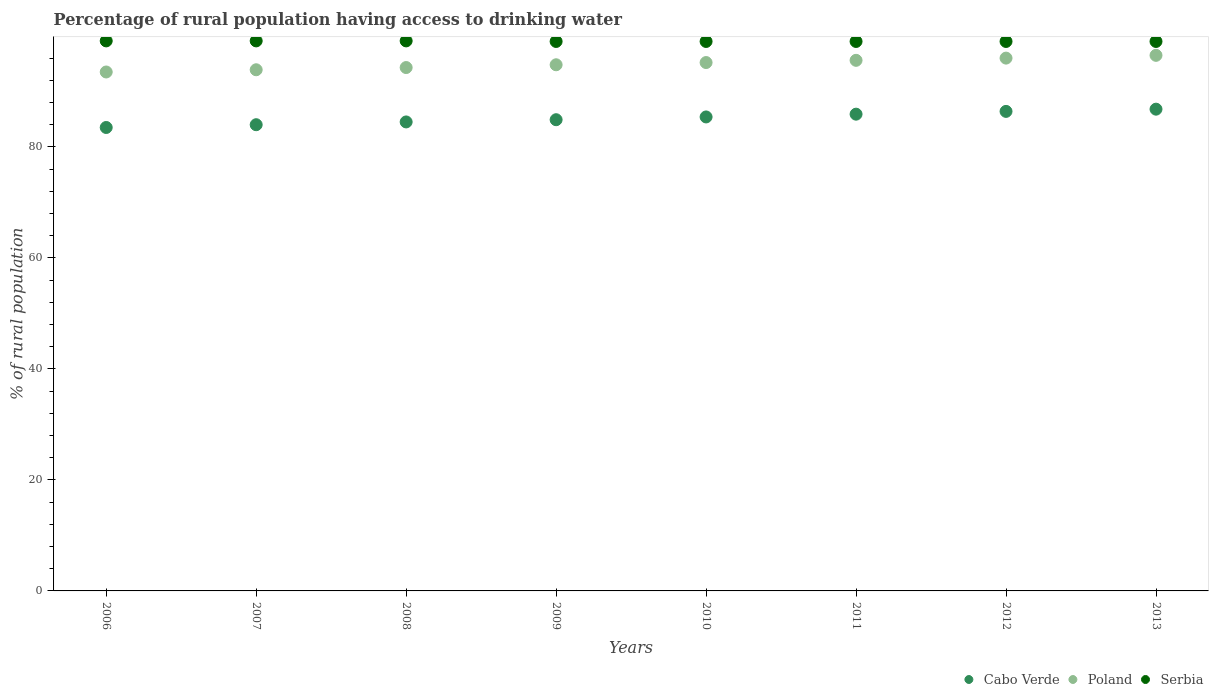Is the number of dotlines equal to the number of legend labels?
Your answer should be very brief. Yes. What is the percentage of rural population having access to drinking water in Poland in 2011?
Ensure brevity in your answer.  95.6. Across all years, what is the maximum percentage of rural population having access to drinking water in Serbia?
Your answer should be very brief. 99.1. Across all years, what is the minimum percentage of rural population having access to drinking water in Serbia?
Your answer should be very brief. 99. In which year was the percentage of rural population having access to drinking water in Cabo Verde maximum?
Your answer should be compact. 2013. In which year was the percentage of rural population having access to drinking water in Serbia minimum?
Ensure brevity in your answer.  2009. What is the total percentage of rural population having access to drinking water in Poland in the graph?
Provide a short and direct response. 759.8. What is the average percentage of rural population having access to drinking water in Serbia per year?
Provide a short and direct response. 99.04. In the year 2012, what is the difference between the percentage of rural population having access to drinking water in Poland and percentage of rural population having access to drinking water in Cabo Verde?
Keep it short and to the point. 9.6. In how many years, is the percentage of rural population having access to drinking water in Poland greater than 92 %?
Your response must be concise. 8. Is the percentage of rural population having access to drinking water in Poland in 2008 less than that in 2013?
Your response must be concise. Yes. Is the difference between the percentage of rural population having access to drinking water in Poland in 2009 and 2013 greater than the difference between the percentage of rural population having access to drinking water in Cabo Verde in 2009 and 2013?
Offer a terse response. Yes. What is the difference between the highest and the lowest percentage of rural population having access to drinking water in Cabo Verde?
Offer a terse response. 3.3. Is it the case that in every year, the sum of the percentage of rural population having access to drinking water in Poland and percentage of rural population having access to drinking water in Serbia  is greater than the percentage of rural population having access to drinking water in Cabo Verde?
Provide a short and direct response. Yes. Does the percentage of rural population having access to drinking water in Serbia monotonically increase over the years?
Make the answer very short. No. Is the percentage of rural population having access to drinking water in Poland strictly less than the percentage of rural population having access to drinking water in Serbia over the years?
Offer a terse response. Yes. How many years are there in the graph?
Keep it short and to the point. 8. Are the values on the major ticks of Y-axis written in scientific E-notation?
Provide a short and direct response. No. How many legend labels are there?
Ensure brevity in your answer.  3. How are the legend labels stacked?
Offer a very short reply. Horizontal. What is the title of the graph?
Your answer should be very brief. Percentage of rural population having access to drinking water. Does "Kosovo" appear as one of the legend labels in the graph?
Your answer should be very brief. No. What is the label or title of the X-axis?
Offer a very short reply. Years. What is the label or title of the Y-axis?
Offer a very short reply. % of rural population. What is the % of rural population in Cabo Verde in 2006?
Provide a succinct answer. 83.5. What is the % of rural population in Poland in 2006?
Your response must be concise. 93.5. What is the % of rural population in Serbia in 2006?
Provide a succinct answer. 99.1. What is the % of rural population of Poland in 2007?
Offer a very short reply. 93.9. What is the % of rural population of Serbia in 2007?
Your answer should be compact. 99.1. What is the % of rural population of Cabo Verde in 2008?
Provide a short and direct response. 84.5. What is the % of rural population in Poland in 2008?
Make the answer very short. 94.3. What is the % of rural population of Serbia in 2008?
Ensure brevity in your answer.  99.1. What is the % of rural population of Cabo Verde in 2009?
Offer a terse response. 84.9. What is the % of rural population of Poland in 2009?
Provide a succinct answer. 94.8. What is the % of rural population in Serbia in 2009?
Your answer should be compact. 99. What is the % of rural population in Cabo Verde in 2010?
Your answer should be compact. 85.4. What is the % of rural population in Poland in 2010?
Keep it short and to the point. 95.2. What is the % of rural population in Serbia in 2010?
Provide a short and direct response. 99. What is the % of rural population in Cabo Verde in 2011?
Provide a succinct answer. 85.9. What is the % of rural population in Poland in 2011?
Your response must be concise. 95.6. What is the % of rural population in Serbia in 2011?
Keep it short and to the point. 99. What is the % of rural population in Cabo Verde in 2012?
Provide a succinct answer. 86.4. What is the % of rural population of Poland in 2012?
Give a very brief answer. 96. What is the % of rural population in Cabo Verde in 2013?
Provide a short and direct response. 86.8. What is the % of rural population in Poland in 2013?
Your answer should be very brief. 96.5. Across all years, what is the maximum % of rural population of Cabo Verde?
Offer a terse response. 86.8. Across all years, what is the maximum % of rural population in Poland?
Provide a succinct answer. 96.5. Across all years, what is the maximum % of rural population in Serbia?
Offer a very short reply. 99.1. Across all years, what is the minimum % of rural population in Cabo Verde?
Provide a succinct answer. 83.5. Across all years, what is the minimum % of rural population of Poland?
Offer a very short reply. 93.5. What is the total % of rural population of Cabo Verde in the graph?
Give a very brief answer. 681.4. What is the total % of rural population of Poland in the graph?
Your answer should be compact. 759.8. What is the total % of rural population in Serbia in the graph?
Keep it short and to the point. 792.3. What is the difference between the % of rural population of Cabo Verde in 2006 and that in 2007?
Your response must be concise. -0.5. What is the difference between the % of rural population in Poland in 2006 and that in 2007?
Provide a succinct answer. -0.4. What is the difference between the % of rural population of Serbia in 2006 and that in 2007?
Provide a short and direct response. 0. What is the difference between the % of rural population of Cabo Verde in 2006 and that in 2008?
Make the answer very short. -1. What is the difference between the % of rural population in Poland in 2006 and that in 2008?
Your answer should be compact. -0.8. What is the difference between the % of rural population of Serbia in 2006 and that in 2008?
Your response must be concise. 0. What is the difference between the % of rural population of Cabo Verde in 2006 and that in 2010?
Your answer should be compact. -1.9. What is the difference between the % of rural population of Cabo Verde in 2006 and that in 2011?
Your answer should be compact. -2.4. What is the difference between the % of rural population in Serbia in 2006 and that in 2011?
Keep it short and to the point. 0.1. What is the difference between the % of rural population of Cabo Verde in 2006 and that in 2012?
Your answer should be compact. -2.9. What is the difference between the % of rural population of Serbia in 2006 and that in 2012?
Your answer should be very brief. 0.1. What is the difference between the % of rural population in Cabo Verde in 2006 and that in 2013?
Offer a very short reply. -3.3. What is the difference between the % of rural population of Serbia in 2006 and that in 2013?
Your answer should be compact. 0.1. What is the difference between the % of rural population of Cabo Verde in 2007 and that in 2009?
Offer a terse response. -0.9. What is the difference between the % of rural population in Cabo Verde in 2007 and that in 2010?
Offer a very short reply. -1.4. What is the difference between the % of rural population of Cabo Verde in 2007 and that in 2011?
Provide a short and direct response. -1.9. What is the difference between the % of rural population in Poland in 2007 and that in 2011?
Your answer should be very brief. -1.7. What is the difference between the % of rural population in Serbia in 2007 and that in 2011?
Your response must be concise. 0.1. What is the difference between the % of rural population in Cabo Verde in 2007 and that in 2012?
Your answer should be very brief. -2.4. What is the difference between the % of rural population of Serbia in 2007 and that in 2012?
Your answer should be compact. 0.1. What is the difference between the % of rural population in Poland in 2008 and that in 2009?
Provide a succinct answer. -0.5. What is the difference between the % of rural population of Cabo Verde in 2008 and that in 2010?
Keep it short and to the point. -0.9. What is the difference between the % of rural population in Serbia in 2008 and that in 2010?
Provide a succinct answer. 0.1. What is the difference between the % of rural population of Serbia in 2008 and that in 2011?
Make the answer very short. 0.1. What is the difference between the % of rural population in Poland in 2009 and that in 2010?
Your response must be concise. -0.4. What is the difference between the % of rural population of Serbia in 2009 and that in 2010?
Your response must be concise. 0. What is the difference between the % of rural population of Cabo Verde in 2009 and that in 2011?
Provide a succinct answer. -1. What is the difference between the % of rural population of Serbia in 2009 and that in 2011?
Your answer should be very brief. 0. What is the difference between the % of rural population of Cabo Verde in 2009 and that in 2012?
Your answer should be very brief. -1.5. What is the difference between the % of rural population of Cabo Verde in 2009 and that in 2013?
Offer a very short reply. -1.9. What is the difference between the % of rural population in Poland in 2009 and that in 2013?
Your response must be concise. -1.7. What is the difference between the % of rural population in Serbia in 2009 and that in 2013?
Your answer should be very brief. 0. What is the difference between the % of rural population of Cabo Verde in 2010 and that in 2012?
Ensure brevity in your answer.  -1. What is the difference between the % of rural population of Serbia in 2010 and that in 2013?
Provide a short and direct response. 0. What is the difference between the % of rural population in Cabo Verde in 2011 and that in 2012?
Make the answer very short. -0.5. What is the difference between the % of rural population of Serbia in 2011 and that in 2012?
Your answer should be compact. 0. What is the difference between the % of rural population of Poland in 2012 and that in 2013?
Provide a succinct answer. -0.5. What is the difference between the % of rural population in Serbia in 2012 and that in 2013?
Offer a very short reply. 0. What is the difference between the % of rural population in Cabo Verde in 2006 and the % of rural population in Serbia in 2007?
Ensure brevity in your answer.  -15.6. What is the difference between the % of rural population in Poland in 2006 and the % of rural population in Serbia in 2007?
Give a very brief answer. -5.6. What is the difference between the % of rural population of Cabo Verde in 2006 and the % of rural population of Serbia in 2008?
Offer a terse response. -15.6. What is the difference between the % of rural population of Poland in 2006 and the % of rural population of Serbia in 2008?
Give a very brief answer. -5.6. What is the difference between the % of rural population of Cabo Verde in 2006 and the % of rural population of Serbia in 2009?
Provide a succinct answer. -15.5. What is the difference between the % of rural population in Cabo Verde in 2006 and the % of rural population in Poland in 2010?
Your answer should be very brief. -11.7. What is the difference between the % of rural population in Cabo Verde in 2006 and the % of rural population in Serbia in 2010?
Your answer should be compact. -15.5. What is the difference between the % of rural population of Poland in 2006 and the % of rural population of Serbia in 2010?
Offer a terse response. -5.5. What is the difference between the % of rural population of Cabo Verde in 2006 and the % of rural population of Serbia in 2011?
Offer a very short reply. -15.5. What is the difference between the % of rural population of Cabo Verde in 2006 and the % of rural population of Poland in 2012?
Offer a terse response. -12.5. What is the difference between the % of rural population of Cabo Verde in 2006 and the % of rural population of Serbia in 2012?
Ensure brevity in your answer.  -15.5. What is the difference between the % of rural population in Poland in 2006 and the % of rural population in Serbia in 2012?
Offer a very short reply. -5.5. What is the difference between the % of rural population in Cabo Verde in 2006 and the % of rural population in Poland in 2013?
Keep it short and to the point. -13. What is the difference between the % of rural population of Cabo Verde in 2006 and the % of rural population of Serbia in 2013?
Give a very brief answer. -15.5. What is the difference between the % of rural population of Poland in 2006 and the % of rural population of Serbia in 2013?
Offer a very short reply. -5.5. What is the difference between the % of rural population of Cabo Verde in 2007 and the % of rural population of Serbia in 2008?
Your answer should be compact. -15.1. What is the difference between the % of rural population in Cabo Verde in 2007 and the % of rural population in Poland in 2009?
Keep it short and to the point. -10.8. What is the difference between the % of rural population in Poland in 2007 and the % of rural population in Serbia in 2009?
Ensure brevity in your answer.  -5.1. What is the difference between the % of rural population in Cabo Verde in 2007 and the % of rural population in Poland in 2010?
Keep it short and to the point. -11.2. What is the difference between the % of rural population of Cabo Verde in 2007 and the % of rural population of Serbia in 2010?
Your response must be concise. -15. What is the difference between the % of rural population of Cabo Verde in 2007 and the % of rural population of Serbia in 2011?
Ensure brevity in your answer.  -15. What is the difference between the % of rural population of Cabo Verde in 2007 and the % of rural population of Poland in 2012?
Give a very brief answer. -12. What is the difference between the % of rural population in Cabo Verde in 2007 and the % of rural population in Serbia in 2012?
Your response must be concise. -15. What is the difference between the % of rural population of Poland in 2007 and the % of rural population of Serbia in 2012?
Ensure brevity in your answer.  -5.1. What is the difference between the % of rural population in Cabo Verde in 2007 and the % of rural population in Poland in 2013?
Your response must be concise. -12.5. What is the difference between the % of rural population of Cabo Verde in 2008 and the % of rural population of Poland in 2009?
Make the answer very short. -10.3. What is the difference between the % of rural population in Cabo Verde in 2008 and the % of rural population in Serbia in 2009?
Provide a short and direct response. -14.5. What is the difference between the % of rural population in Cabo Verde in 2008 and the % of rural population in Poland in 2010?
Your response must be concise. -10.7. What is the difference between the % of rural population in Poland in 2008 and the % of rural population in Serbia in 2010?
Keep it short and to the point. -4.7. What is the difference between the % of rural population of Cabo Verde in 2008 and the % of rural population of Poland in 2011?
Your answer should be compact. -11.1. What is the difference between the % of rural population in Poland in 2008 and the % of rural population in Serbia in 2011?
Make the answer very short. -4.7. What is the difference between the % of rural population of Cabo Verde in 2008 and the % of rural population of Poland in 2012?
Your answer should be very brief. -11.5. What is the difference between the % of rural population in Cabo Verde in 2008 and the % of rural population in Serbia in 2012?
Your response must be concise. -14.5. What is the difference between the % of rural population of Poland in 2008 and the % of rural population of Serbia in 2012?
Your answer should be compact. -4.7. What is the difference between the % of rural population in Poland in 2008 and the % of rural population in Serbia in 2013?
Offer a terse response. -4.7. What is the difference between the % of rural population in Cabo Verde in 2009 and the % of rural population in Poland in 2010?
Ensure brevity in your answer.  -10.3. What is the difference between the % of rural population in Cabo Verde in 2009 and the % of rural population in Serbia in 2010?
Keep it short and to the point. -14.1. What is the difference between the % of rural population of Cabo Verde in 2009 and the % of rural population of Poland in 2011?
Make the answer very short. -10.7. What is the difference between the % of rural population in Cabo Verde in 2009 and the % of rural population in Serbia in 2011?
Your answer should be very brief. -14.1. What is the difference between the % of rural population of Poland in 2009 and the % of rural population of Serbia in 2011?
Ensure brevity in your answer.  -4.2. What is the difference between the % of rural population of Cabo Verde in 2009 and the % of rural population of Poland in 2012?
Offer a very short reply. -11.1. What is the difference between the % of rural population in Cabo Verde in 2009 and the % of rural population in Serbia in 2012?
Offer a very short reply. -14.1. What is the difference between the % of rural population of Poland in 2009 and the % of rural population of Serbia in 2012?
Give a very brief answer. -4.2. What is the difference between the % of rural population of Cabo Verde in 2009 and the % of rural population of Poland in 2013?
Provide a succinct answer. -11.6. What is the difference between the % of rural population of Cabo Verde in 2009 and the % of rural population of Serbia in 2013?
Your answer should be compact. -14.1. What is the difference between the % of rural population of Poland in 2009 and the % of rural population of Serbia in 2013?
Keep it short and to the point. -4.2. What is the difference between the % of rural population in Cabo Verde in 2010 and the % of rural population in Poland in 2012?
Ensure brevity in your answer.  -10.6. What is the difference between the % of rural population of Cabo Verde in 2011 and the % of rural population of Poland in 2012?
Give a very brief answer. -10.1. What is the difference between the % of rural population of Cabo Verde in 2011 and the % of rural population of Serbia in 2012?
Provide a short and direct response. -13.1. What is the difference between the % of rural population of Cabo Verde in 2011 and the % of rural population of Serbia in 2013?
Provide a short and direct response. -13.1. What is the difference between the % of rural population of Cabo Verde in 2012 and the % of rural population of Poland in 2013?
Offer a terse response. -10.1. What is the difference between the % of rural population in Poland in 2012 and the % of rural population in Serbia in 2013?
Your response must be concise. -3. What is the average % of rural population in Cabo Verde per year?
Offer a very short reply. 85.17. What is the average % of rural population of Poland per year?
Keep it short and to the point. 94.97. What is the average % of rural population in Serbia per year?
Keep it short and to the point. 99.04. In the year 2006, what is the difference between the % of rural population of Cabo Verde and % of rural population of Poland?
Keep it short and to the point. -10. In the year 2006, what is the difference between the % of rural population of Cabo Verde and % of rural population of Serbia?
Give a very brief answer. -15.6. In the year 2007, what is the difference between the % of rural population of Cabo Verde and % of rural population of Serbia?
Offer a terse response. -15.1. In the year 2008, what is the difference between the % of rural population in Cabo Verde and % of rural population in Serbia?
Offer a very short reply. -14.6. In the year 2009, what is the difference between the % of rural population in Cabo Verde and % of rural population in Serbia?
Provide a succinct answer. -14.1. In the year 2010, what is the difference between the % of rural population in Cabo Verde and % of rural population in Poland?
Keep it short and to the point. -9.8. In the year 2011, what is the difference between the % of rural population of Cabo Verde and % of rural population of Serbia?
Offer a terse response. -13.1. In the year 2011, what is the difference between the % of rural population of Poland and % of rural population of Serbia?
Provide a short and direct response. -3.4. In the year 2012, what is the difference between the % of rural population in Cabo Verde and % of rural population in Poland?
Keep it short and to the point. -9.6. In the year 2012, what is the difference between the % of rural population of Poland and % of rural population of Serbia?
Provide a short and direct response. -3. In the year 2013, what is the difference between the % of rural population in Cabo Verde and % of rural population in Poland?
Your answer should be compact. -9.7. In the year 2013, what is the difference between the % of rural population in Cabo Verde and % of rural population in Serbia?
Give a very brief answer. -12.2. In the year 2013, what is the difference between the % of rural population in Poland and % of rural population in Serbia?
Make the answer very short. -2.5. What is the ratio of the % of rural population of Cabo Verde in 2006 to that in 2007?
Offer a very short reply. 0.99. What is the ratio of the % of rural population in Poland in 2006 to that in 2007?
Ensure brevity in your answer.  1. What is the ratio of the % of rural population of Serbia in 2006 to that in 2007?
Your answer should be very brief. 1. What is the ratio of the % of rural population of Cabo Verde in 2006 to that in 2008?
Provide a short and direct response. 0.99. What is the ratio of the % of rural population of Cabo Verde in 2006 to that in 2009?
Provide a short and direct response. 0.98. What is the ratio of the % of rural population of Poland in 2006 to that in 2009?
Keep it short and to the point. 0.99. What is the ratio of the % of rural population in Cabo Verde in 2006 to that in 2010?
Ensure brevity in your answer.  0.98. What is the ratio of the % of rural population of Poland in 2006 to that in 2010?
Keep it short and to the point. 0.98. What is the ratio of the % of rural population in Serbia in 2006 to that in 2010?
Ensure brevity in your answer.  1. What is the ratio of the % of rural population of Cabo Verde in 2006 to that in 2011?
Provide a short and direct response. 0.97. What is the ratio of the % of rural population of Poland in 2006 to that in 2011?
Provide a succinct answer. 0.98. What is the ratio of the % of rural population in Serbia in 2006 to that in 2011?
Offer a very short reply. 1. What is the ratio of the % of rural population of Cabo Verde in 2006 to that in 2012?
Make the answer very short. 0.97. What is the ratio of the % of rural population in Cabo Verde in 2006 to that in 2013?
Provide a succinct answer. 0.96. What is the ratio of the % of rural population of Poland in 2006 to that in 2013?
Ensure brevity in your answer.  0.97. What is the ratio of the % of rural population of Serbia in 2006 to that in 2013?
Make the answer very short. 1. What is the ratio of the % of rural population of Cabo Verde in 2007 to that in 2008?
Offer a terse response. 0.99. What is the ratio of the % of rural population of Cabo Verde in 2007 to that in 2009?
Provide a short and direct response. 0.99. What is the ratio of the % of rural population in Serbia in 2007 to that in 2009?
Your answer should be compact. 1. What is the ratio of the % of rural population of Cabo Verde in 2007 to that in 2010?
Ensure brevity in your answer.  0.98. What is the ratio of the % of rural population of Poland in 2007 to that in 2010?
Your response must be concise. 0.99. What is the ratio of the % of rural population in Serbia in 2007 to that in 2010?
Offer a terse response. 1. What is the ratio of the % of rural population of Cabo Verde in 2007 to that in 2011?
Ensure brevity in your answer.  0.98. What is the ratio of the % of rural population of Poland in 2007 to that in 2011?
Keep it short and to the point. 0.98. What is the ratio of the % of rural population in Serbia in 2007 to that in 2011?
Offer a very short reply. 1. What is the ratio of the % of rural population of Cabo Verde in 2007 to that in 2012?
Make the answer very short. 0.97. What is the ratio of the % of rural population in Poland in 2007 to that in 2012?
Your answer should be very brief. 0.98. What is the ratio of the % of rural population of Cabo Verde in 2007 to that in 2013?
Keep it short and to the point. 0.97. What is the ratio of the % of rural population of Poland in 2007 to that in 2013?
Keep it short and to the point. 0.97. What is the ratio of the % of rural population in Serbia in 2007 to that in 2013?
Keep it short and to the point. 1. What is the ratio of the % of rural population in Cabo Verde in 2008 to that in 2011?
Offer a terse response. 0.98. What is the ratio of the % of rural population in Poland in 2008 to that in 2011?
Provide a short and direct response. 0.99. What is the ratio of the % of rural population in Serbia in 2008 to that in 2011?
Ensure brevity in your answer.  1. What is the ratio of the % of rural population of Poland in 2008 to that in 2012?
Provide a succinct answer. 0.98. What is the ratio of the % of rural population of Cabo Verde in 2008 to that in 2013?
Give a very brief answer. 0.97. What is the ratio of the % of rural population of Poland in 2008 to that in 2013?
Make the answer very short. 0.98. What is the ratio of the % of rural population in Serbia in 2009 to that in 2010?
Your answer should be compact. 1. What is the ratio of the % of rural population in Cabo Verde in 2009 to that in 2011?
Your answer should be compact. 0.99. What is the ratio of the % of rural population in Poland in 2009 to that in 2011?
Provide a short and direct response. 0.99. What is the ratio of the % of rural population in Serbia in 2009 to that in 2011?
Your answer should be very brief. 1. What is the ratio of the % of rural population of Cabo Verde in 2009 to that in 2012?
Offer a very short reply. 0.98. What is the ratio of the % of rural population of Poland in 2009 to that in 2012?
Give a very brief answer. 0.99. What is the ratio of the % of rural population in Cabo Verde in 2009 to that in 2013?
Make the answer very short. 0.98. What is the ratio of the % of rural population in Poland in 2009 to that in 2013?
Your response must be concise. 0.98. What is the ratio of the % of rural population of Serbia in 2009 to that in 2013?
Provide a succinct answer. 1. What is the ratio of the % of rural population of Poland in 2010 to that in 2011?
Your response must be concise. 1. What is the ratio of the % of rural population of Cabo Verde in 2010 to that in 2012?
Your answer should be compact. 0.99. What is the ratio of the % of rural population of Poland in 2010 to that in 2012?
Your answer should be very brief. 0.99. What is the ratio of the % of rural population of Serbia in 2010 to that in 2012?
Your answer should be very brief. 1. What is the ratio of the % of rural population in Cabo Verde in 2010 to that in 2013?
Provide a succinct answer. 0.98. What is the ratio of the % of rural population of Poland in 2010 to that in 2013?
Offer a very short reply. 0.99. What is the ratio of the % of rural population in Cabo Verde in 2011 to that in 2012?
Give a very brief answer. 0.99. What is the ratio of the % of rural population in Poland in 2011 to that in 2012?
Your answer should be compact. 1. What is the ratio of the % of rural population in Cabo Verde in 2011 to that in 2013?
Provide a short and direct response. 0.99. What is the ratio of the % of rural population of Poland in 2011 to that in 2013?
Give a very brief answer. 0.99. What is the ratio of the % of rural population of Serbia in 2011 to that in 2013?
Provide a short and direct response. 1. What is the ratio of the % of rural population of Cabo Verde in 2012 to that in 2013?
Your answer should be very brief. 1. What is the difference between the highest and the lowest % of rural population in Cabo Verde?
Provide a short and direct response. 3.3. 